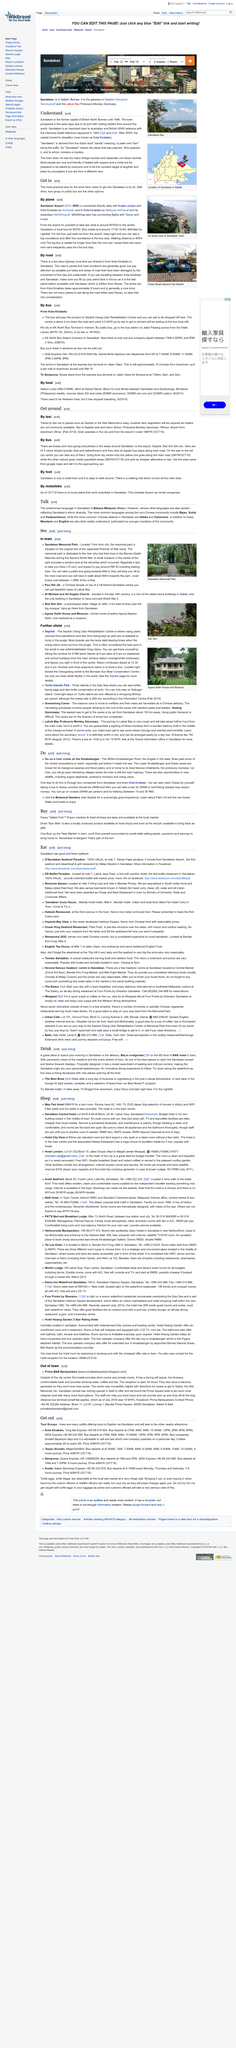Indicate a few pertinent items in this graphic. The above photograph was taken at Sandakan Bay, which is located in Sandakan, Malaysia. Will the negotiation of fares be required, as meters are not commonly available... Sandakan was the former capital of British North Borneo until 1946, when it was replaced by Kota Kinabalu. The entire trip from Kota Kinabalu takes approximately 6 hours. The road from Kota Kinabalu to Sendakan is paved, as confirmed. 